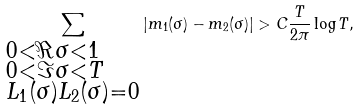<formula> <loc_0><loc_0><loc_500><loc_500>\sum _ { \begin{subarray} { c } 0 < \Re { \sigma } < 1 \\ 0 < \Im { \sigma } < T \\ L _ { 1 } ( \sigma ) L _ { 2 } ( \sigma ) = 0 \end{subarray} } | m _ { 1 } ( \sigma ) - m _ { 2 } ( \sigma ) | > C \frac { T } { 2 \pi } \log { T } ,</formula> 